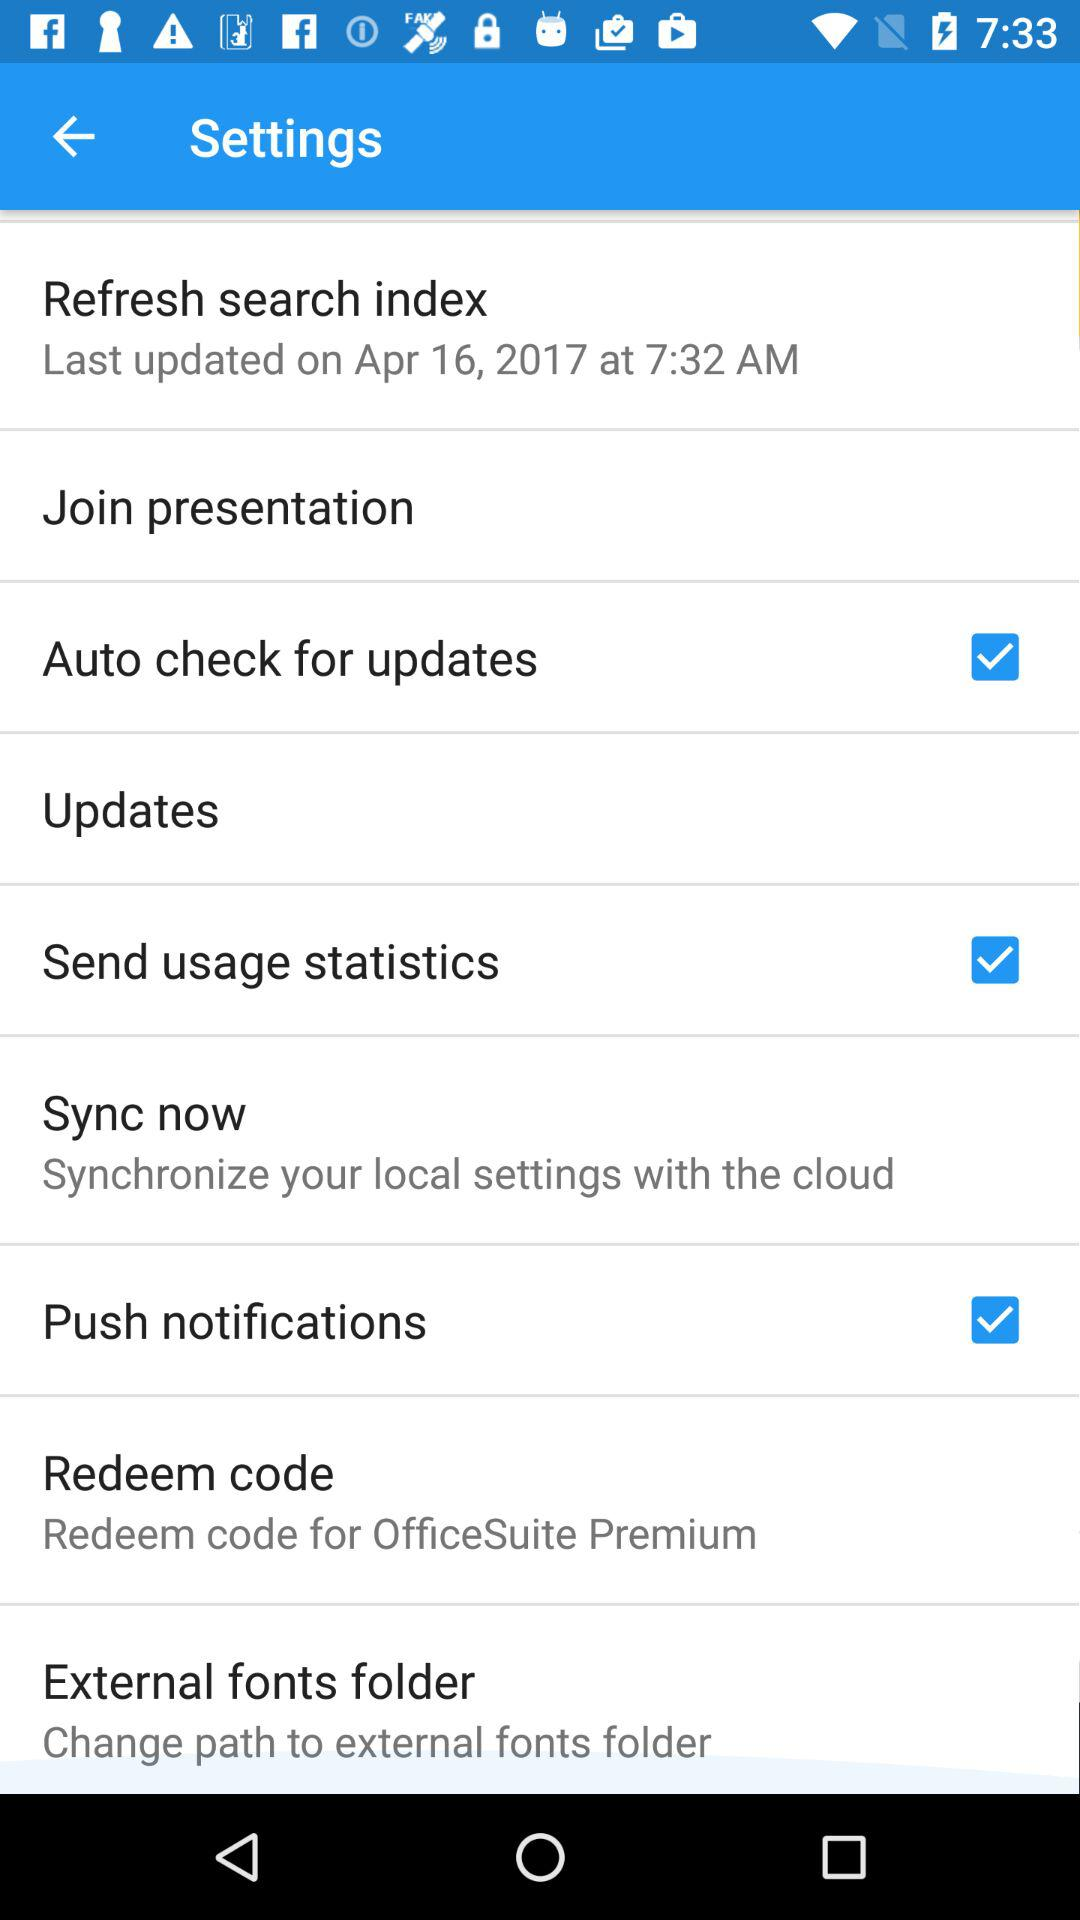When was the last update made? The last update was made on April 16, 2017 at 7:32 AM. 